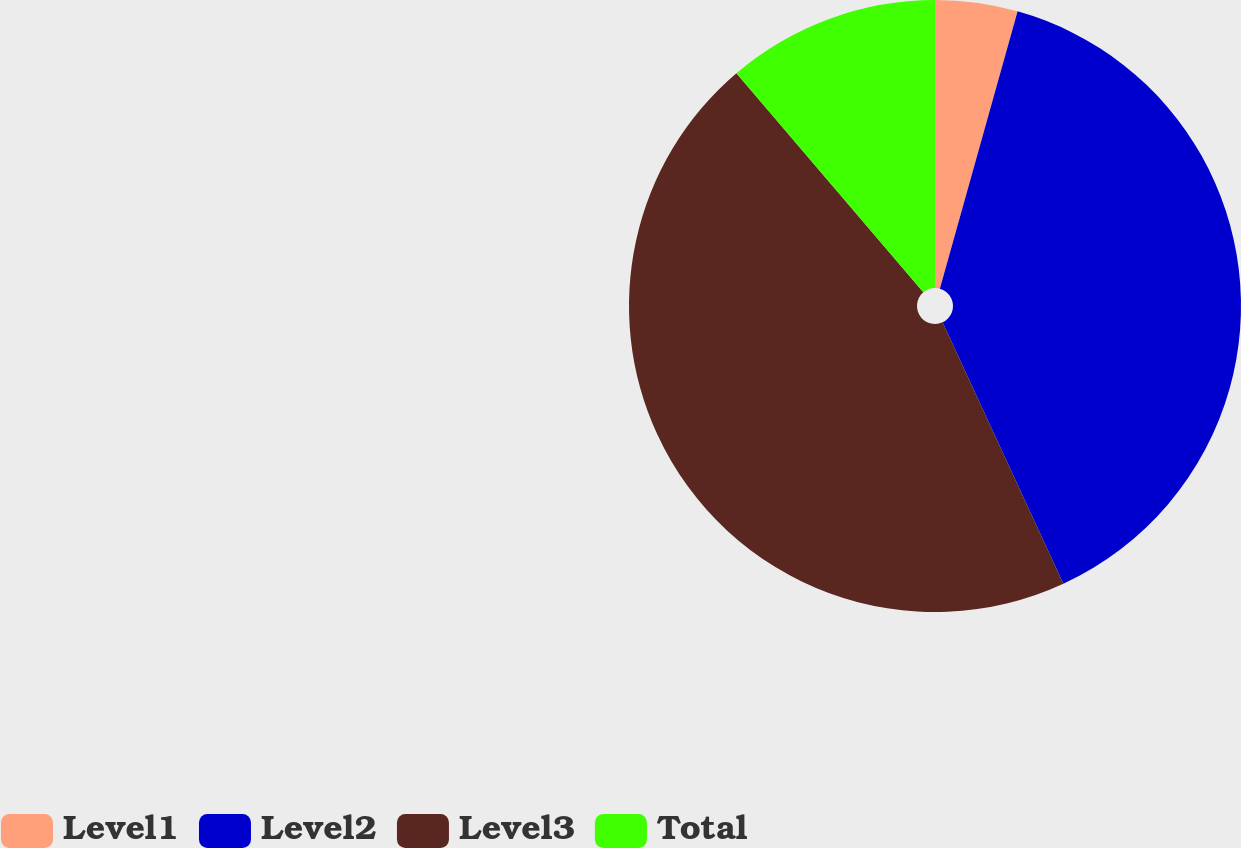<chart> <loc_0><loc_0><loc_500><loc_500><pie_chart><fcel>Level1<fcel>Level2<fcel>Level3<fcel>Total<nl><fcel>4.35%<fcel>38.76%<fcel>45.65%<fcel>11.24%<nl></chart> 